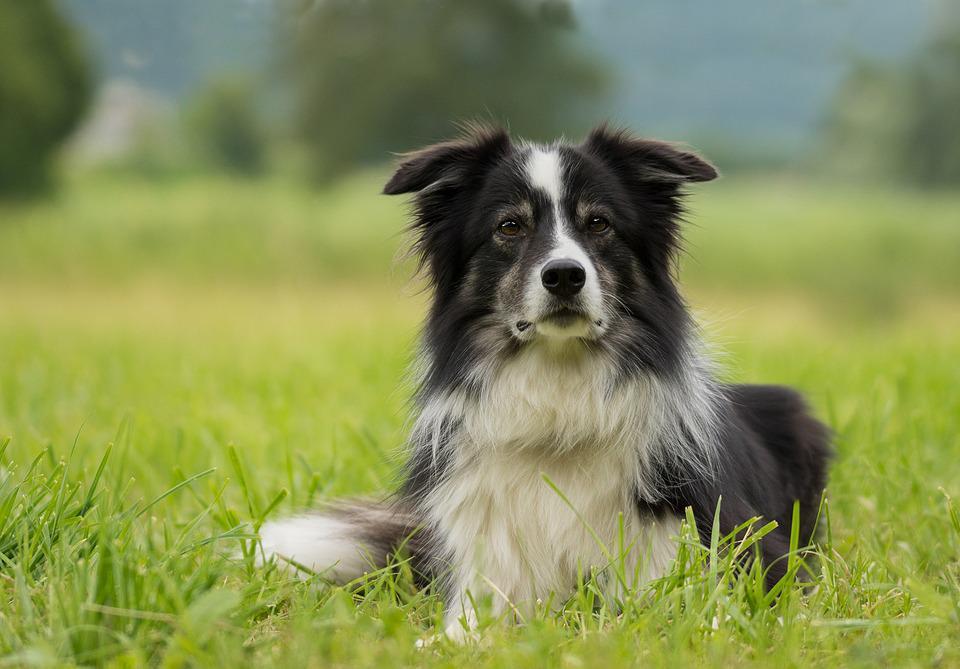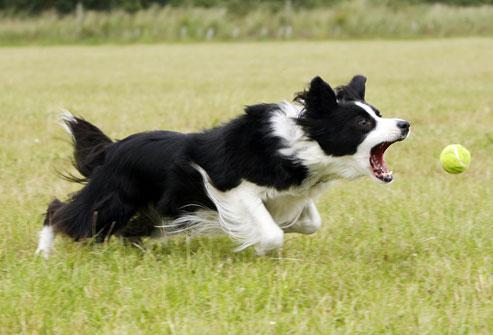The first image is the image on the left, the second image is the image on the right. Assess this claim about the two images: "One of the dogs is lying on grass with its head up.". Correct or not? Answer yes or no. Yes. The first image is the image on the left, the second image is the image on the right. Assess this claim about the two images: "There is one border calling laying down in the grass.". Correct or not? Answer yes or no. Yes. 